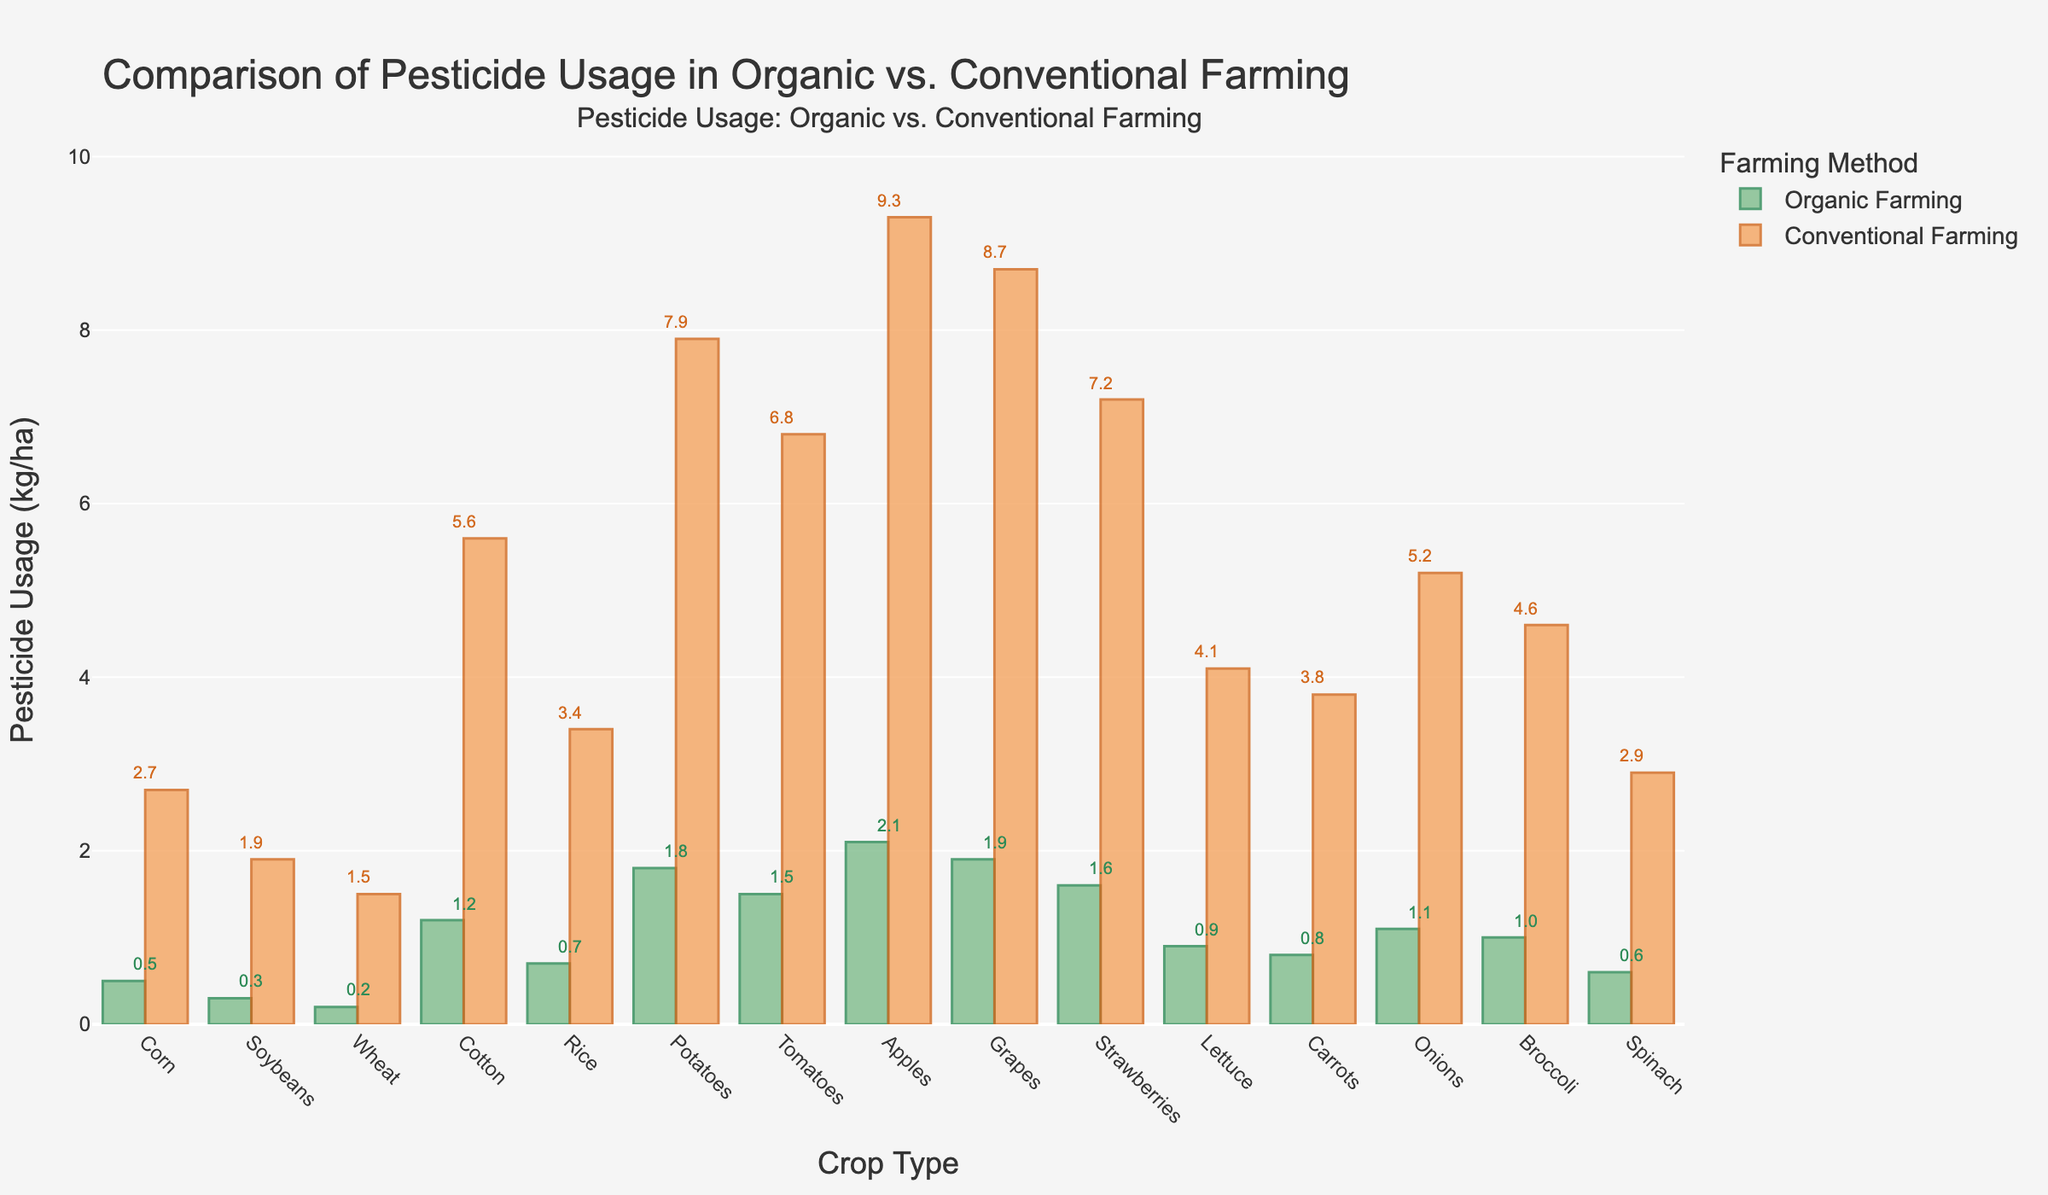what is the total pesticide usage for wheat in both farming methods? Add the pesticide usage for organic farming (0.2 kg/ha) and conventional farming (1.5 kg/ha). 0.2 + 1.5 = 1.7 kg/ha.
Answer: 1.7 kg/ha Which crop type shows the largest difference in pesticide usage between organic and conventional farming? The difference for each crop type needs to be calculated: Corn (2.2 kg/ha), Soybeans (1.6 kg/ha), Wheat (1.3 kg/ha), Cotton (4.4 kg/ha), Rice (2.7 kg/ha), Potatoes (6.1 kg/ha), Tomatoes (5.3 kg/ha), Apples (7.2 kg/ha), Grapes (6.8 kg/ha), Strawberries (5.6 kg/ha), Lettuce (3.2 kg/ha), Carrots (3.0 kg/ha), Onions (4.1 kg/ha), Broccoli (3.6 kg/ha), Spinach (2.3 kg/ha). The largest difference is for Apples at 7.2 kg/ha.
Answer: Apples On average, how much pesticide is used per hectare in conventional farming? Sum the pesticide usages for all crops under conventional farming and divide by the number of crops: (2.7 + 1.9 + 1.5 + 5.6 + 3.4 + 7.9 + 6.8 + 9.3 + 8.7 + 7.2 + 4.1 + 3.8 + 5.2 + 4.6 + 2.9) / 15 = 75.6 / 15 = 5.04 kg/ha.
Answer: 5.04 kg/ha What color represents pesticide usage in organic farming in the bar chart? The visual representation of the organic farming bars is noted by their distinct color. The bars for organic farming are colored green.
Answer: Green Which crop has the lowest pesticide usage in organic farming? Look at the heights of the green bars representing organic farming. The smallest bar correlates with Wheat, which has a pesticide usage of 0.2 kg/ha.
Answer: Wheat How many crops have a pesticide usage higher than 1.0 kg/ha in organic farming? Count the crop types with green bars exceeding 1.0 kg/ha: Cotton (1.2 kg/ha), Potatoes (1.8 kg/ha), Tomatoes (1.5 kg/ha), Apples (2.1 kg/ha), Grapes (1.9 kg/ha), Strawberries (1.6 kg/ha), Onions (1.1 kg/ha), Broccoli (1.0 kg/ha). There are 8 such crops.
Answer: 8 What is the ratio of pesticide usage between organic and conventional farming for corn? Divide the pesticide usage for organic farming (0.5 kg/ha) by that for conventional farming (2.7 kg/ha). 0.5 / 2.7 ≈ 0.185
Answer: 0.185 If organic farming reduces pesticide usage by 70% compared to conventional farming, what is the expected reduction for rice in kg/ha? Calculate 70% of conventional farming usage for rice (3.4 kg/ha). 70% of 3.4 kg/ha is (0.7 * 3.4) = 2.38 kg/ha.
Answer: 2.38 kg/ha 